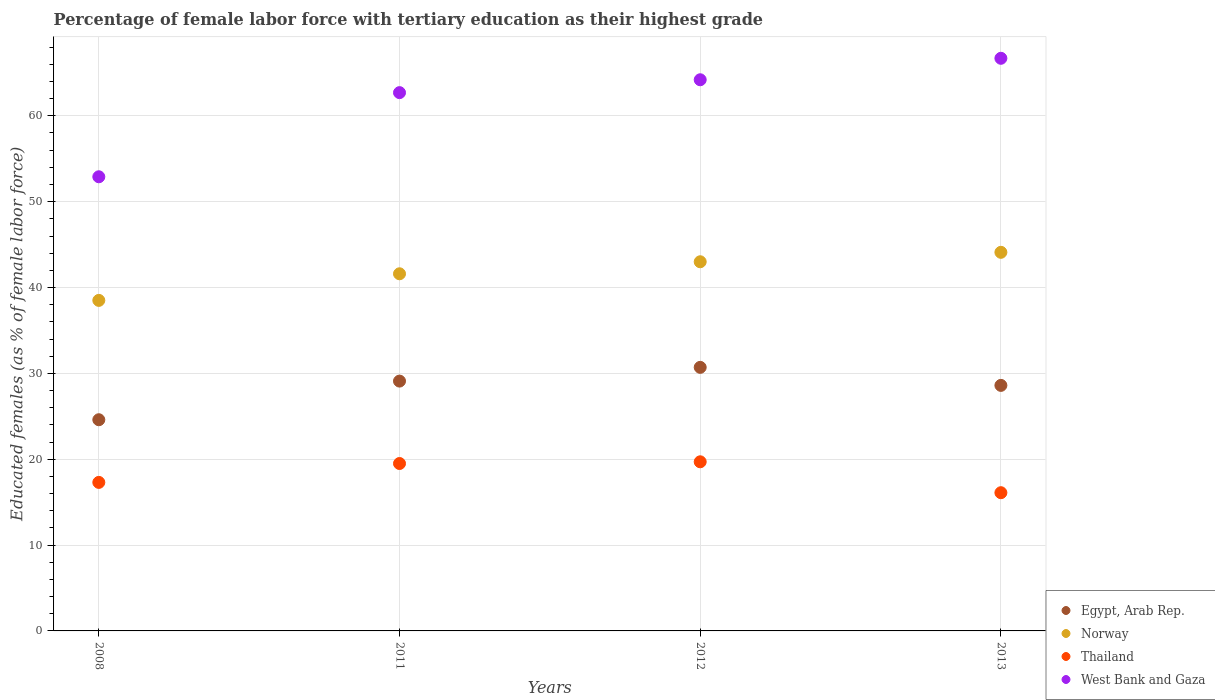Is the number of dotlines equal to the number of legend labels?
Your answer should be compact. Yes. What is the percentage of female labor force with tertiary education in Egypt, Arab Rep. in 2012?
Make the answer very short. 30.7. Across all years, what is the maximum percentage of female labor force with tertiary education in Egypt, Arab Rep.?
Keep it short and to the point. 30.7. Across all years, what is the minimum percentage of female labor force with tertiary education in West Bank and Gaza?
Make the answer very short. 52.9. What is the total percentage of female labor force with tertiary education in West Bank and Gaza in the graph?
Offer a very short reply. 246.5. What is the difference between the percentage of female labor force with tertiary education in West Bank and Gaza in 2008 and that in 2013?
Offer a terse response. -13.8. What is the difference between the percentage of female labor force with tertiary education in Egypt, Arab Rep. in 2013 and the percentage of female labor force with tertiary education in Thailand in 2008?
Give a very brief answer. 11.3. What is the average percentage of female labor force with tertiary education in West Bank and Gaza per year?
Offer a very short reply. 61.62. In the year 2013, what is the difference between the percentage of female labor force with tertiary education in Thailand and percentage of female labor force with tertiary education in Norway?
Give a very brief answer. -28. In how many years, is the percentage of female labor force with tertiary education in Egypt, Arab Rep. greater than 52 %?
Provide a short and direct response. 0. What is the ratio of the percentage of female labor force with tertiary education in Thailand in 2012 to that in 2013?
Give a very brief answer. 1.22. What is the difference between the highest and the second highest percentage of female labor force with tertiary education in Thailand?
Your answer should be compact. 0.2. What is the difference between the highest and the lowest percentage of female labor force with tertiary education in West Bank and Gaza?
Offer a terse response. 13.8. Is it the case that in every year, the sum of the percentage of female labor force with tertiary education in Thailand and percentage of female labor force with tertiary education in Norway  is greater than the sum of percentage of female labor force with tertiary education in West Bank and Gaza and percentage of female labor force with tertiary education in Egypt, Arab Rep.?
Keep it short and to the point. No. Does the percentage of female labor force with tertiary education in Egypt, Arab Rep. monotonically increase over the years?
Offer a very short reply. No. What is the difference between two consecutive major ticks on the Y-axis?
Your response must be concise. 10. Does the graph contain any zero values?
Provide a succinct answer. No. What is the title of the graph?
Provide a short and direct response. Percentage of female labor force with tertiary education as their highest grade. Does "Botswana" appear as one of the legend labels in the graph?
Make the answer very short. No. What is the label or title of the X-axis?
Your answer should be very brief. Years. What is the label or title of the Y-axis?
Keep it short and to the point. Educated females (as % of female labor force). What is the Educated females (as % of female labor force) of Egypt, Arab Rep. in 2008?
Your response must be concise. 24.6. What is the Educated females (as % of female labor force) of Norway in 2008?
Provide a short and direct response. 38.5. What is the Educated females (as % of female labor force) in Thailand in 2008?
Your response must be concise. 17.3. What is the Educated females (as % of female labor force) of West Bank and Gaza in 2008?
Your answer should be very brief. 52.9. What is the Educated females (as % of female labor force) of Egypt, Arab Rep. in 2011?
Keep it short and to the point. 29.1. What is the Educated females (as % of female labor force) of Norway in 2011?
Make the answer very short. 41.6. What is the Educated females (as % of female labor force) of West Bank and Gaza in 2011?
Offer a terse response. 62.7. What is the Educated females (as % of female labor force) in Egypt, Arab Rep. in 2012?
Offer a terse response. 30.7. What is the Educated females (as % of female labor force) in Thailand in 2012?
Give a very brief answer. 19.7. What is the Educated females (as % of female labor force) of West Bank and Gaza in 2012?
Offer a terse response. 64.2. What is the Educated females (as % of female labor force) in Egypt, Arab Rep. in 2013?
Your response must be concise. 28.6. What is the Educated females (as % of female labor force) of Norway in 2013?
Make the answer very short. 44.1. What is the Educated females (as % of female labor force) in Thailand in 2013?
Offer a terse response. 16.1. What is the Educated females (as % of female labor force) of West Bank and Gaza in 2013?
Make the answer very short. 66.7. Across all years, what is the maximum Educated females (as % of female labor force) in Egypt, Arab Rep.?
Give a very brief answer. 30.7. Across all years, what is the maximum Educated females (as % of female labor force) in Norway?
Make the answer very short. 44.1. Across all years, what is the maximum Educated females (as % of female labor force) in Thailand?
Your response must be concise. 19.7. Across all years, what is the maximum Educated females (as % of female labor force) of West Bank and Gaza?
Give a very brief answer. 66.7. Across all years, what is the minimum Educated females (as % of female labor force) of Egypt, Arab Rep.?
Offer a terse response. 24.6. Across all years, what is the minimum Educated females (as % of female labor force) of Norway?
Provide a succinct answer. 38.5. Across all years, what is the minimum Educated females (as % of female labor force) of Thailand?
Ensure brevity in your answer.  16.1. Across all years, what is the minimum Educated females (as % of female labor force) in West Bank and Gaza?
Ensure brevity in your answer.  52.9. What is the total Educated females (as % of female labor force) in Egypt, Arab Rep. in the graph?
Your answer should be compact. 113. What is the total Educated females (as % of female labor force) in Norway in the graph?
Your answer should be very brief. 167.2. What is the total Educated females (as % of female labor force) of Thailand in the graph?
Make the answer very short. 72.6. What is the total Educated females (as % of female labor force) in West Bank and Gaza in the graph?
Offer a very short reply. 246.5. What is the difference between the Educated females (as % of female labor force) of Egypt, Arab Rep. in 2008 and that in 2011?
Offer a terse response. -4.5. What is the difference between the Educated females (as % of female labor force) of Norway in 2008 and that in 2011?
Give a very brief answer. -3.1. What is the difference between the Educated females (as % of female labor force) in Thailand in 2008 and that in 2011?
Make the answer very short. -2.2. What is the difference between the Educated females (as % of female labor force) of Thailand in 2008 and that in 2013?
Give a very brief answer. 1.2. What is the difference between the Educated females (as % of female labor force) in West Bank and Gaza in 2008 and that in 2013?
Provide a short and direct response. -13.8. What is the difference between the Educated females (as % of female labor force) in Egypt, Arab Rep. in 2011 and that in 2012?
Keep it short and to the point. -1.6. What is the difference between the Educated females (as % of female labor force) in West Bank and Gaza in 2011 and that in 2012?
Ensure brevity in your answer.  -1.5. What is the difference between the Educated females (as % of female labor force) in Norway in 2011 and that in 2013?
Your answer should be compact. -2.5. What is the difference between the Educated females (as % of female labor force) in Thailand in 2011 and that in 2013?
Your response must be concise. 3.4. What is the difference between the Educated females (as % of female labor force) of West Bank and Gaza in 2011 and that in 2013?
Make the answer very short. -4. What is the difference between the Educated females (as % of female labor force) in West Bank and Gaza in 2012 and that in 2013?
Ensure brevity in your answer.  -2.5. What is the difference between the Educated females (as % of female labor force) of Egypt, Arab Rep. in 2008 and the Educated females (as % of female labor force) of Norway in 2011?
Give a very brief answer. -17. What is the difference between the Educated females (as % of female labor force) in Egypt, Arab Rep. in 2008 and the Educated females (as % of female labor force) in Thailand in 2011?
Make the answer very short. 5.1. What is the difference between the Educated females (as % of female labor force) of Egypt, Arab Rep. in 2008 and the Educated females (as % of female labor force) of West Bank and Gaza in 2011?
Offer a terse response. -38.1. What is the difference between the Educated females (as % of female labor force) of Norway in 2008 and the Educated females (as % of female labor force) of Thailand in 2011?
Offer a terse response. 19. What is the difference between the Educated females (as % of female labor force) in Norway in 2008 and the Educated females (as % of female labor force) in West Bank and Gaza in 2011?
Keep it short and to the point. -24.2. What is the difference between the Educated females (as % of female labor force) of Thailand in 2008 and the Educated females (as % of female labor force) of West Bank and Gaza in 2011?
Your answer should be very brief. -45.4. What is the difference between the Educated females (as % of female labor force) in Egypt, Arab Rep. in 2008 and the Educated females (as % of female labor force) in Norway in 2012?
Keep it short and to the point. -18.4. What is the difference between the Educated females (as % of female labor force) in Egypt, Arab Rep. in 2008 and the Educated females (as % of female labor force) in West Bank and Gaza in 2012?
Your response must be concise. -39.6. What is the difference between the Educated females (as % of female labor force) in Norway in 2008 and the Educated females (as % of female labor force) in West Bank and Gaza in 2012?
Give a very brief answer. -25.7. What is the difference between the Educated females (as % of female labor force) in Thailand in 2008 and the Educated females (as % of female labor force) in West Bank and Gaza in 2012?
Your answer should be compact. -46.9. What is the difference between the Educated females (as % of female labor force) in Egypt, Arab Rep. in 2008 and the Educated females (as % of female labor force) in Norway in 2013?
Give a very brief answer. -19.5. What is the difference between the Educated females (as % of female labor force) in Egypt, Arab Rep. in 2008 and the Educated females (as % of female labor force) in Thailand in 2013?
Your answer should be compact. 8.5. What is the difference between the Educated females (as % of female labor force) in Egypt, Arab Rep. in 2008 and the Educated females (as % of female labor force) in West Bank and Gaza in 2013?
Provide a short and direct response. -42.1. What is the difference between the Educated females (as % of female labor force) of Norway in 2008 and the Educated females (as % of female labor force) of Thailand in 2013?
Your answer should be compact. 22.4. What is the difference between the Educated females (as % of female labor force) of Norway in 2008 and the Educated females (as % of female labor force) of West Bank and Gaza in 2013?
Your answer should be compact. -28.2. What is the difference between the Educated females (as % of female labor force) in Thailand in 2008 and the Educated females (as % of female labor force) in West Bank and Gaza in 2013?
Ensure brevity in your answer.  -49.4. What is the difference between the Educated females (as % of female labor force) of Egypt, Arab Rep. in 2011 and the Educated females (as % of female labor force) of West Bank and Gaza in 2012?
Keep it short and to the point. -35.1. What is the difference between the Educated females (as % of female labor force) of Norway in 2011 and the Educated females (as % of female labor force) of Thailand in 2012?
Keep it short and to the point. 21.9. What is the difference between the Educated females (as % of female labor force) in Norway in 2011 and the Educated females (as % of female labor force) in West Bank and Gaza in 2012?
Your answer should be compact. -22.6. What is the difference between the Educated females (as % of female labor force) in Thailand in 2011 and the Educated females (as % of female labor force) in West Bank and Gaza in 2012?
Provide a short and direct response. -44.7. What is the difference between the Educated females (as % of female labor force) of Egypt, Arab Rep. in 2011 and the Educated females (as % of female labor force) of Thailand in 2013?
Your answer should be very brief. 13. What is the difference between the Educated females (as % of female labor force) in Egypt, Arab Rep. in 2011 and the Educated females (as % of female labor force) in West Bank and Gaza in 2013?
Your answer should be compact. -37.6. What is the difference between the Educated females (as % of female labor force) in Norway in 2011 and the Educated females (as % of female labor force) in Thailand in 2013?
Provide a succinct answer. 25.5. What is the difference between the Educated females (as % of female labor force) in Norway in 2011 and the Educated females (as % of female labor force) in West Bank and Gaza in 2013?
Give a very brief answer. -25.1. What is the difference between the Educated females (as % of female labor force) of Thailand in 2011 and the Educated females (as % of female labor force) of West Bank and Gaza in 2013?
Provide a short and direct response. -47.2. What is the difference between the Educated females (as % of female labor force) of Egypt, Arab Rep. in 2012 and the Educated females (as % of female labor force) of West Bank and Gaza in 2013?
Your response must be concise. -36. What is the difference between the Educated females (as % of female labor force) in Norway in 2012 and the Educated females (as % of female labor force) in Thailand in 2013?
Keep it short and to the point. 26.9. What is the difference between the Educated females (as % of female labor force) of Norway in 2012 and the Educated females (as % of female labor force) of West Bank and Gaza in 2013?
Your answer should be compact. -23.7. What is the difference between the Educated females (as % of female labor force) in Thailand in 2012 and the Educated females (as % of female labor force) in West Bank and Gaza in 2013?
Provide a succinct answer. -47. What is the average Educated females (as % of female labor force) in Egypt, Arab Rep. per year?
Offer a terse response. 28.25. What is the average Educated females (as % of female labor force) in Norway per year?
Your answer should be compact. 41.8. What is the average Educated females (as % of female labor force) of Thailand per year?
Make the answer very short. 18.15. What is the average Educated females (as % of female labor force) in West Bank and Gaza per year?
Offer a very short reply. 61.62. In the year 2008, what is the difference between the Educated females (as % of female labor force) in Egypt, Arab Rep. and Educated females (as % of female labor force) in Norway?
Provide a short and direct response. -13.9. In the year 2008, what is the difference between the Educated females (as % of female labor force) of Egypt, Arab Rep. and Educated females (as % of female labor force) of West Bank and Gaza?
Your answer should be compact. -28.3. In the year 2008, what is the difference between the Educated females (as % of female labor force) in Norway and Educated females (as % of female labor force) in Thailand?
Offer a very short reply. 21.2. In the year 2008, what is the difference between the Educated females (as % of female labor force) in Norway and Educated females (as % of female labor force) in West Bank and Gaza?
Provide a succinct answer. -14.4. In the year 2008, what is the difference between the Educated females (as % of female labor force) of Thailand and Educated females (as % of female labor force) of West Bank and Gaza?
Your response must be concise. -35.6. In the year 2011, what is the difference between the Educated females (as % of female labor force) in Egypt, Arab Rep. and Educated females (as % of female labor force) in West Bank and Gaza?
Provide a short and direct response. -33.6. In the year 2011, what is the difference between the Educated females (as % of female labor force) of Norway and Educated females (as % of female labor force) of Thailand?
Offer a very short reply. 22.1. In the year 2011, what is the difference between the Educated females (as % of female labor force) in Norway and Educated females (as % of female labor force) in West Bank and Gaza?
Your answer should be compact. -21.1. In the year 2011, what is the difference between the Educated females (as % of female labor force) of Thailand and Educated females (as % of female labor force) of West Bank and Gaza?
Your response must be concise. -43.2. In the year 2012, what is the difference between the Educated females (as % of female labor force) in Egypt, Arab Rep. and Educated females (as % of female labor force) in Norway?
Your answer should be compact. -12.3. In the year 2012, what is the difference between the Educated females (as % of female labor force) of Egypt, Arab Rep. and Educated females (as % of female labor force) of West Bank and Gaza?
Ensure brevity in your answer.  -33.5. In the year 2012, what is the difference between the Educated females (as % of female labor force) of Norway and Educated females (as % of female labor force) of Thailand?
Keep it short and to the point. 23.3. In the year 2012, what is the difference between the Educated females (as % of female labor force) of Norway and Educated females (as % of female labor force) of West Bank and Gaza?
Keep it short and to the point. -21.2. In the year 2012, what is the difference between the Educated females (as % of female labor force) in Thailand and Educated females (as % of female labor force) in West Bank and Gaza?
Give a very brief answer. -44.5. In the year 2013, what is the difference between the Educated females (as % of female labor force) in Egypt, Arab Rep. and Educated females (as % of female labor force) in Norway?
Ensure brevity in your answer.  -15.5. In the year 2013, what is the difference between the Educated females (as % of female labor force) in Egypt, Arab Rep. and Educated females (as % of female labor force) in Thailand?
Give a very brief answer. 12.5. In the year 2013, what is the difference between the Educated females (as % of female labor force) in Egypt, Arab Rep. and Educated females (as % of female labor force) in West Bank and Gaza?
Give a very brief answer. -38.1. In the year 2013, what is the difference between the Educated females (as % of female labor force) in Norway and Educated females (as % of female labor force) in Thailand?
Provide a succinct answer. 28. In the year 2013, what is the difference between the Educated females (as % of female labor force) of Norway and Educated females (as % of female labor force) of West Bank and Gaza?
Provide a short and direct response. -22.6. In the year 2013, what is the difference between the Educated females (as % of female labor force) in Thailand and Educated females (as % of female labor force) in West Bank and Gaza?
Keep it short and to the point. -50.6. What is the ratio of the Educated females (as % of female labor force) in Egypt, Arab Rep. in 2008 to that in 2011?
Your answer should be compact. 0.85. What is the ratio of the Educated females (as % of female labor force) of Norway in 2008 to that in 2011?
Provide a succinct answer. 0.93. What is the ratio of the Educated females (as % of female labor force) in Thailand in 2008 to that in 2011?
Offer a terse response. 0.89. What is the ratio of the Educated females (as % of female labor force) in West Bank and Gaza in 2008 to that in 2011?
Provide a succinct answer. 0.84. What is the ratio of the Educated females (as % of female labor force) in Egypt, Arab Rep. in 2008 to that in 2012?
Give a very brief answer. 0.8. What is the ratio of the Educated females (as % of female labor force) in Norway in 2008 to that in 2012?
Your response must be concise. 0.9. What is the ratio of the Educated females (as % of female labor force) in Thailand in 2008 to that in 2012?
Keep it short and to the point. 0.88. What is the ratio of the Educated females (as % of female labor force) in West Bank and Gaza in 2008 to that in 2012?
Your answer should be very brief. 0.82. What is the ratio of the Educated females (as % of female labor force) of Egypt, Arab Rep. in 2008 to that in 2013?
Give a very brief answer. 0.86. What is the ratio of the Educated females (as % of female labor force) of Norway in 2008 to that in 2013?
Your response must be concise. 0.87. What is the ratio of the Educated females (as % of female labor force) of Thailand in 2008 to that in 2013?
Ensure brevity in your answer.  1.07. What is the ratio of the Educated females (as % of female labor force) of West Bank and Gaza in 2008 to that in 2013?
Keep it short and to the point. 0.79. What is the ratio of the Educated females (as % of female labor force) in Egypt, Arab Rep. in 2011 to that in 2012?
Provide a short and direct response. 0.95. What is the ratio of the Educated females (as % of female labor force) of Norway in 2011 to that in 2012?
Provide a short and direct response. 0.97. What is the ratio of the Educated females (as % of female labor force) of Thailand in 2011 to that in 2012?
Offer a very short reply. 0.99. What is the ratio of the Educated females (as % of female labor force) of West Bank and Gaza in 2011 to that in 2012?
Your answer should be compact. 0.98. What is the ratio of the Educated females (as % of female labor force) of Egypt, Arab Rep. in 2011 to that in 2013?
Keep it short and to the point. 1.02. What is the ratio of the Educated females (as % of female labor force) in Norway in 2011 to that in 2013?
Keep it short and to the point. 0.94. What is the ratio of the Educated females (as % of female labor force) of Thailand in 2011 to that in 2013?
Ensure brevity in your answer.  1.21. What is the ratio of the Educated females (as % of female labor force) of Egypt, Arab Rep. in 2012 to that in 2013?
Make the answer very short. 1.07. What is the ratio of the Educated females (as % of female labor force) of Norway in 2012 to that in 2013?
Offer a terse response. 0.98. What is the ratio of the Educated females (as % of female labor force) in Thailand in 2012 to that in 2013?
Provide a short and direct response. 1.22. What is the ratio of the Educated females (as % of female labor force) in West Bank and Gaza in 2012 to that in 2013?
Offer a terse response. 0.96. What is the difference between the highest and the second highest Educated females (as % of female labor force) of Thailand?
Provide a succinct answer. 0.2. What is the difference between the highest and the second highest Educated females (as % of female labor force) of West Bank and Gaza?
Give a very brief answer. 2.5. What is the difference between the highest and the lowest Educated females (as % of female labor force) of Norway?
Provide a succinct answer. 5.6. What is the difference between the highest and the lowest Educated females (as % of female labor force) in Thailand?
Your answer should be very brief. 3.6. 